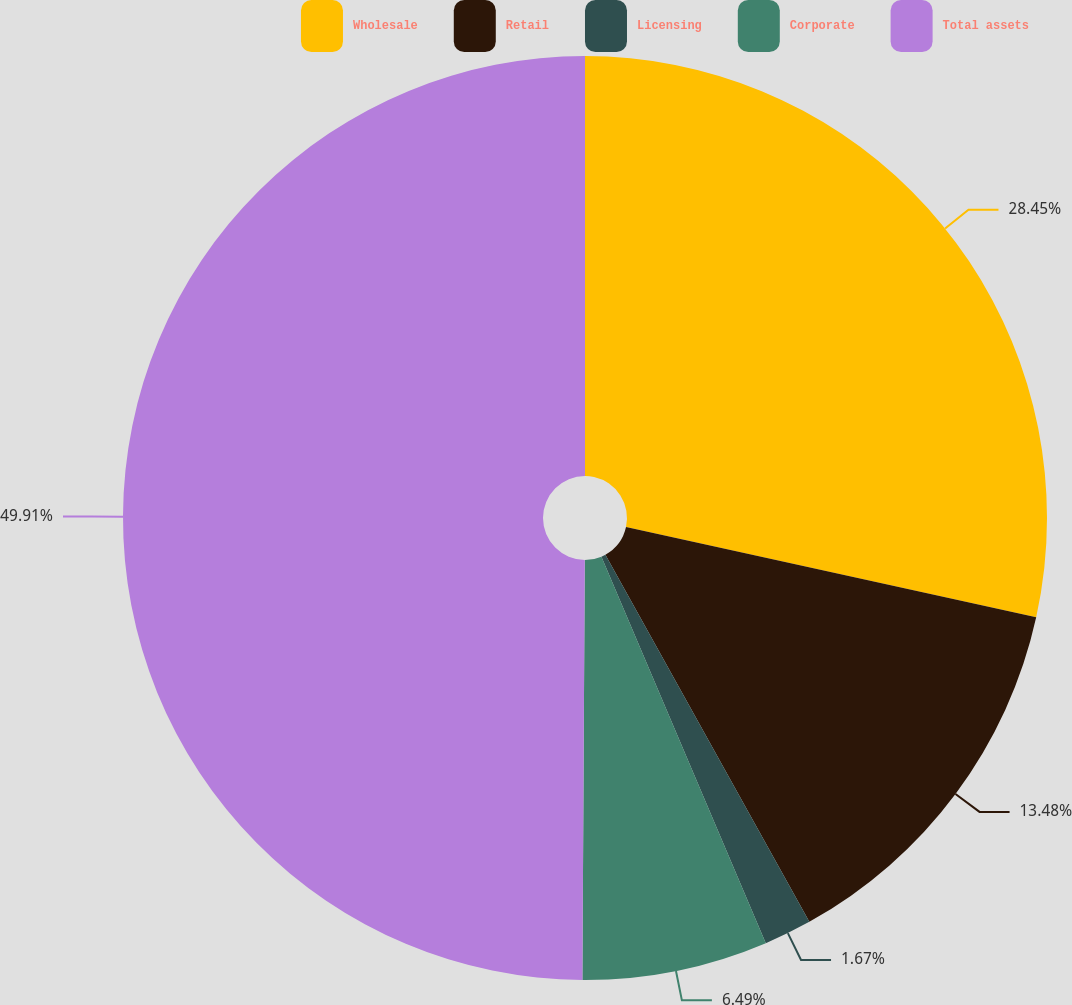Convert chart to OTSL. <chart><loc_0><loc_0><loc_500><loc_500><pie_chart><fcel>Wholesale<fcel>Retail<fcel>Licensing<fcel>Corporate<fcel>Total assets<nl><fcel>28.45%<fcel>13.48%<fcel>1.67%<fcel>6.49%<fcel>49.91%<nl></chart> 